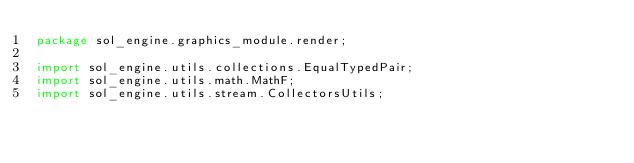Convert code to text. <code><loc_0><loc_0><loc_500><loc_500><_Java_>package sol_engine.graphics_module.render;

import sol_engine.utils.collections.EqualTypedPair;
import sol_engine.utils.math.MathF;
import sol_engine.utils.stream.CollectorsUtils;
</code> 